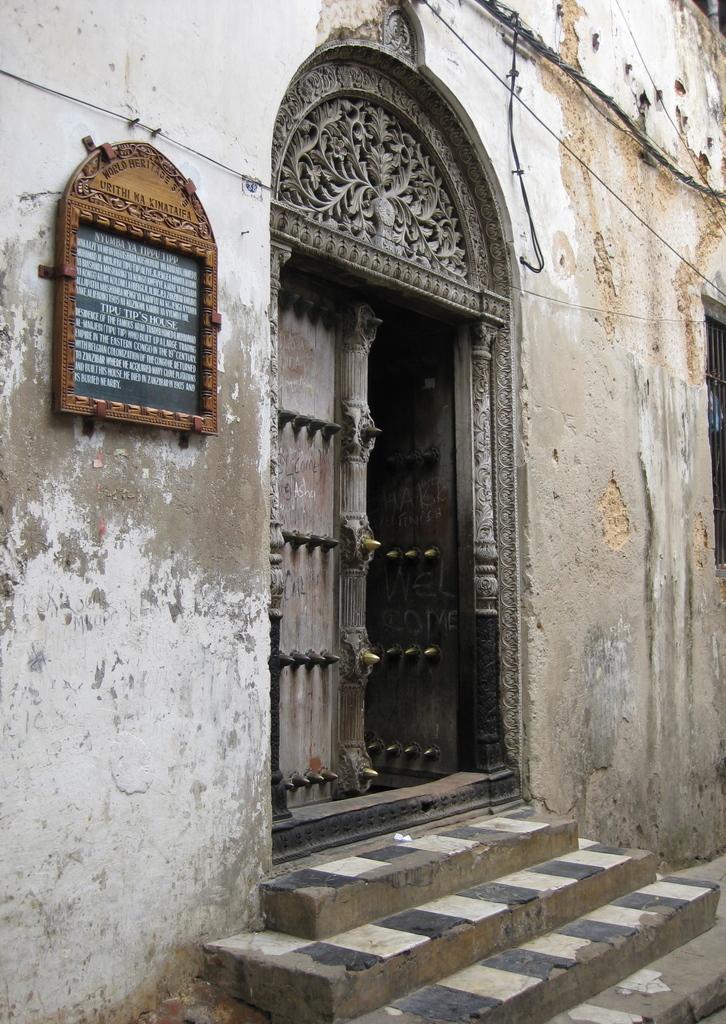In one or two sentences, can you explain what this image depicts? In this picture, we can see a building with door, stairs, and some objects attached to it like a board with some text. 